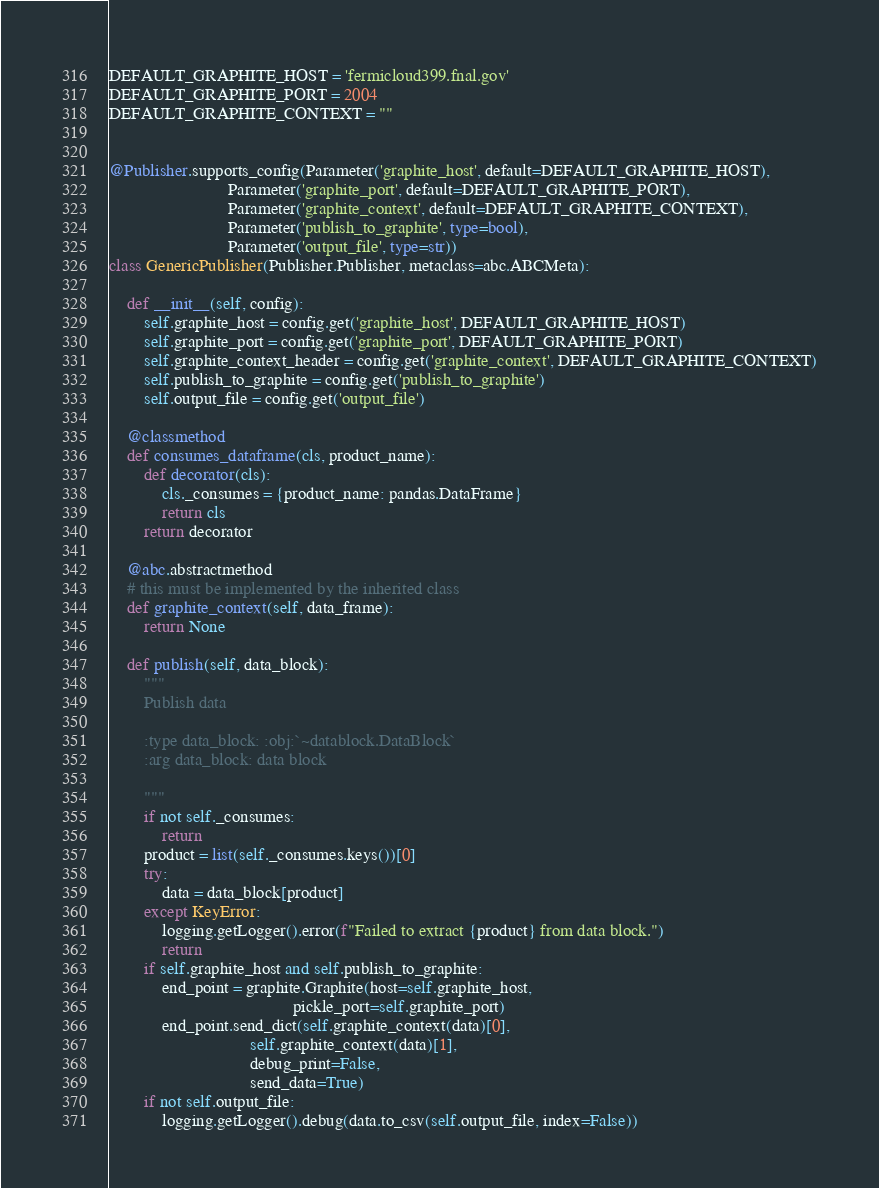<code> <loc_0><loc_0><loc_500><loc_500><_Python_>
DEFAULT_GRAPHITE_HOST = 'fermicloud399.fnal.gov'
DEFAULT_GRAPHITE_PORT = 2004
DEFAULT_GRAPHITE_CONTEXT = ""


@Publisher.supports_config(Parameter('graphite_host', default=DEFAULT_GRAPHITE_HOST),
                           Parameter('graphite_port', default=DEFAULT_GRAPHITE_PORT),
                           Parameter('graphite_context', default=DEFAULT_GRAPHITE_CONTEXT),
                           Parameter('publish_to_graphite', type=bool),
                           Parameter('output_file', type=str))
class GenericPublisher(Publisher.Publisher, metaclass=abc.ABCMeta):

    def __init__(self, config):
        self.graphite_host = config.get('graphite_host', DEFAULT_GRAPHITE_HOST)
        self.graphite_port = config.get('graphite_port', DEFAULT_GRAPHITE_PORT)
        self.graphite_context_header = config.get('graphite_context', DEFAULT_GRAPHITE_CONTEXT)
        self.publish_to_graphite = config.get('publish_to_graphite')
        self.output_file = config.get('output_file')

    @classmethod
    def consumes_dataframe(cls, product_name):
        def decorator(cls):
            cls._consumes = {product_name: pandas.DataFrame}
            return cls
        return decorator

    @abc.abstractmethod
    # this must be implemented by the inherited class
    def graphite_context(self, data_frame):
        return None

    def publish(self, data_block):
        """
        Publish data

        :type data_block: :obj:`~datablock.DataBlock`
        :arg data_block: data block

        """
        if not self._consumes:
            return
        product = list(self._consumes.keys())[0]
        try:
            data = data_block[product]
        except KeyError:
            logging.getLogger().error(f"Failed to extract {product} from data block.")
            return
        if self.graphite_host and self.publish_to_graphite:
            end_point = graphite.Graphite(host=self.graphite_host,
                                          pickle_port=self.graphite_port)
            end_point.send_dict(self.graphite_context(data)[0],
                                self.graphite_context(data)[1],
                                debug_print=False,
                                send_data=True)
        if not self.output_file:
            logging.getLogger().debug(data.to_csv(self.output_file, index=False))
</code> 